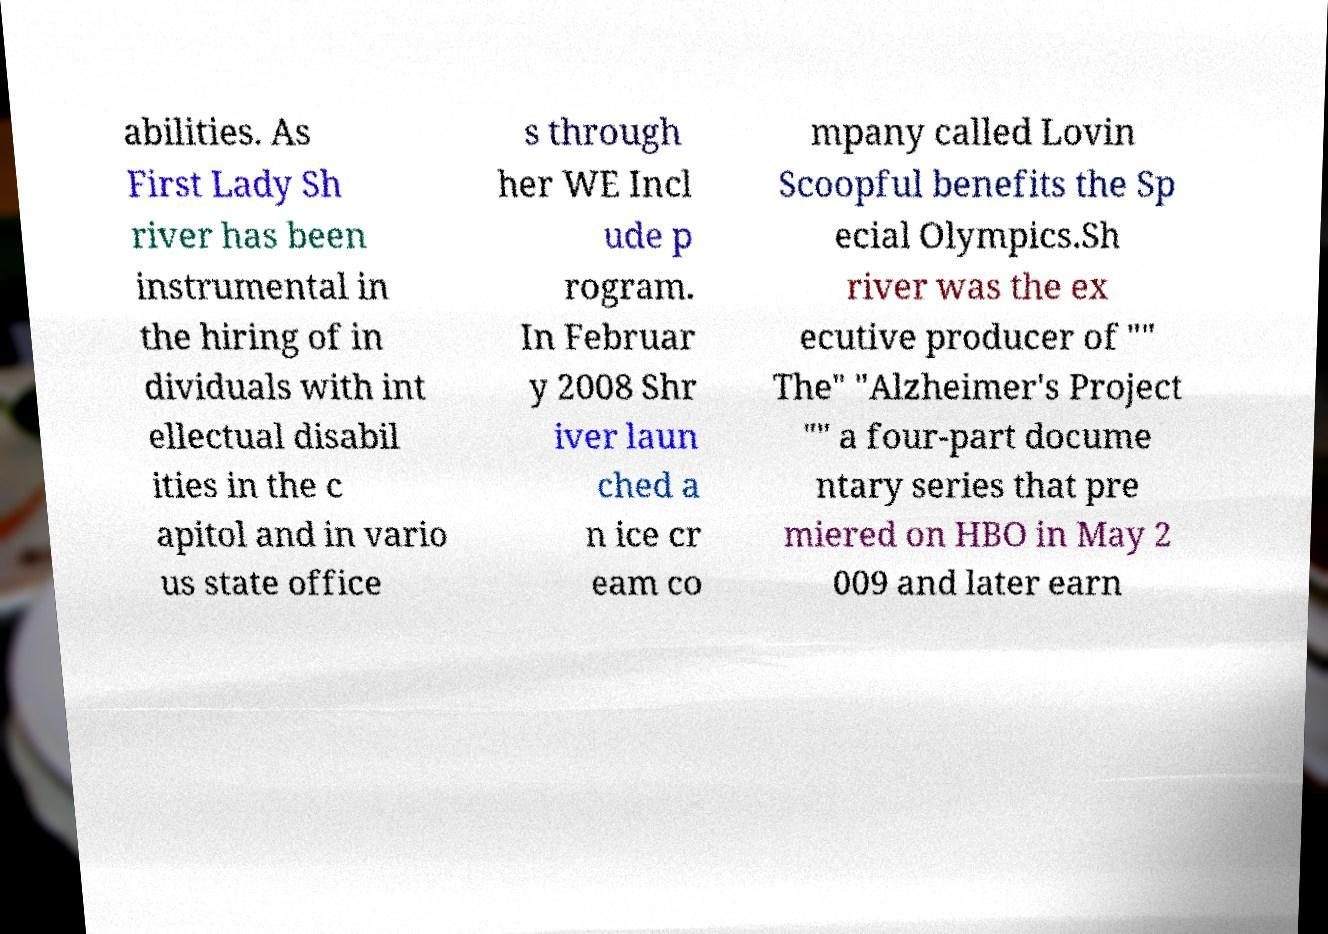Can you read and provide the text displayed in the image?This photo seems to have some interesting text. Can you extract and type it out for me? abilities. As First Lady Sh river has been instrumental in the hiring of in dividuals with int ellectual disabil ities in the c apitol and in vario us state office s through her WE Incl ude p rogram. In Februar y 2008 Shr iver laun ched a n ice cr eam co mpany called Lovin Scoopful benefits the Sp ecial Olympics.Sh river was the ex ecutive producer of "" The" "Alzheimer's Project "" a four-part docume ntary series that pre miered on HBO in May 2 009 and later earn 